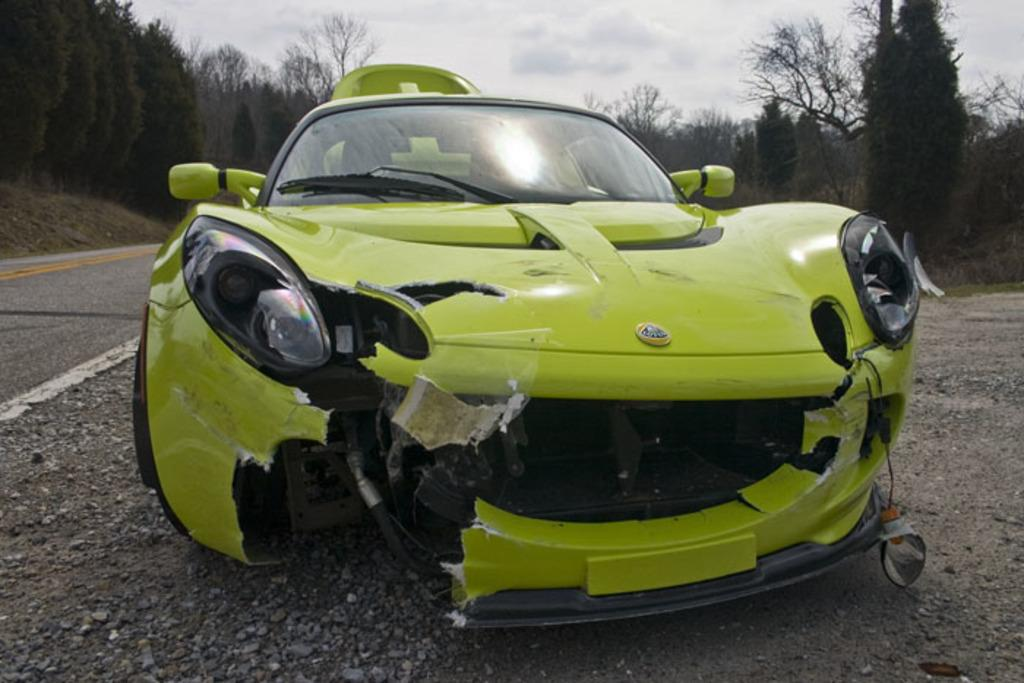What is the main subject of the image? The main subject of the image is a car. Where is the car located in the image? The car is on the road in the image. What can be observed about the car's condition? The front part of the car is damaged. What can be seen in the background of the image? There are trees in the background of the image. What type of pot is visible on the roof of the car in the image? There is no pot visible on the roof of the car in the image. How much fuel is left in the car's tank in the image? The image does not provide information about the car's fuel level. What type of pickle is being used as a windshield wiper in the image? There is no pickle being used as a windshield wiper in the image. 